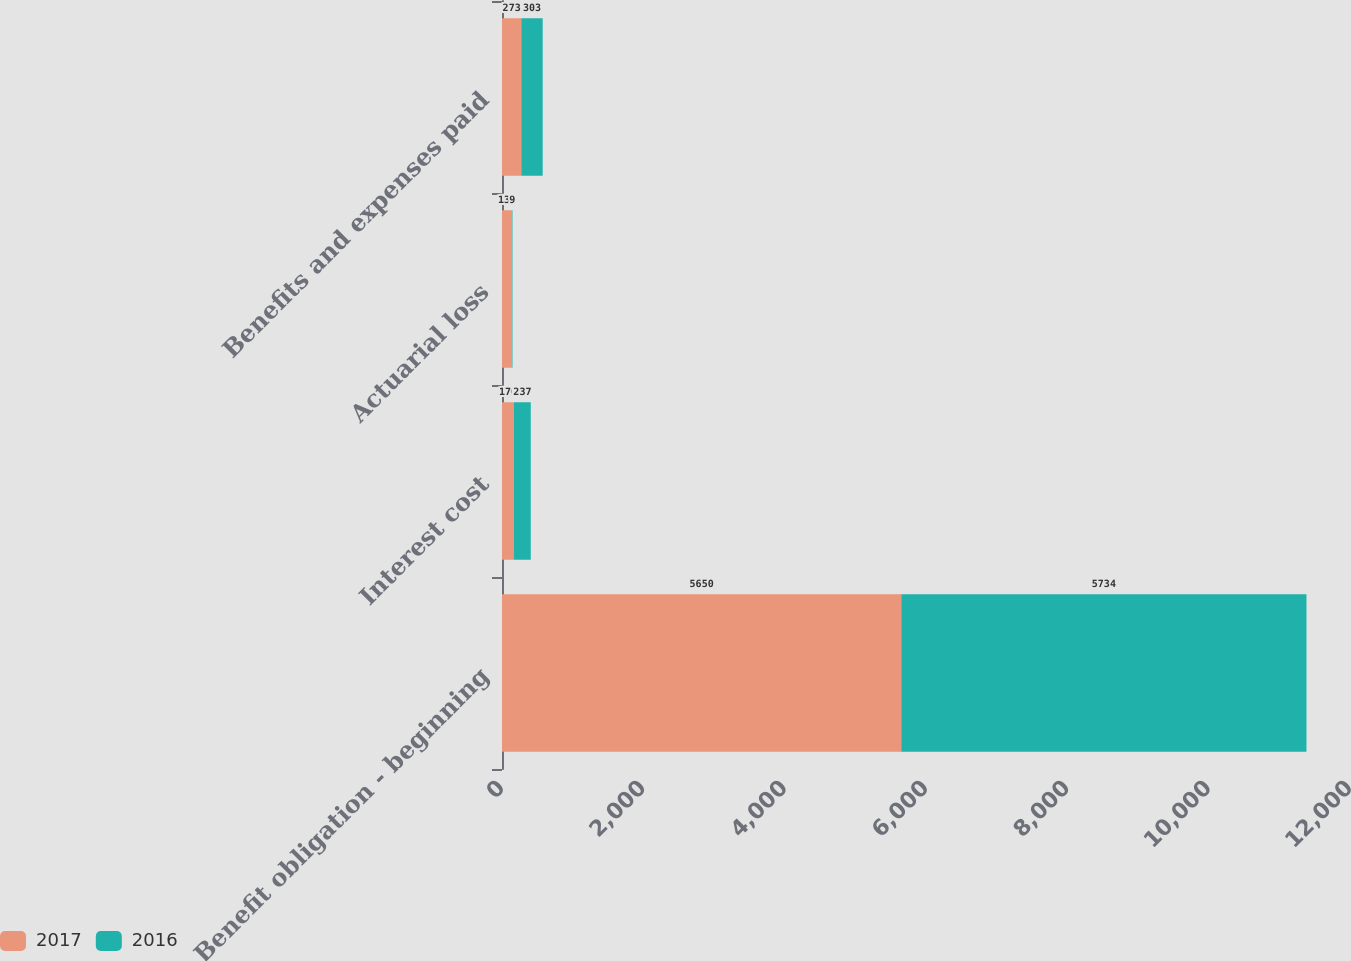Convert chart. <chart><loc_0><loc_0><loc_500><loc_500><stacked_bar_chart><ecel><fcel>Benefit obligation - beginning<fcel>Interest cost<fcel>Actuarial loss<fcel>Benefits and expenses paid<nl><fcel>2017<fcel>5650<fcel>170<fcel>139<fcel>273<nl><fcel>2016<fcel>5734<fcel>237<fcel>9<fcel>303<nl></chart> 